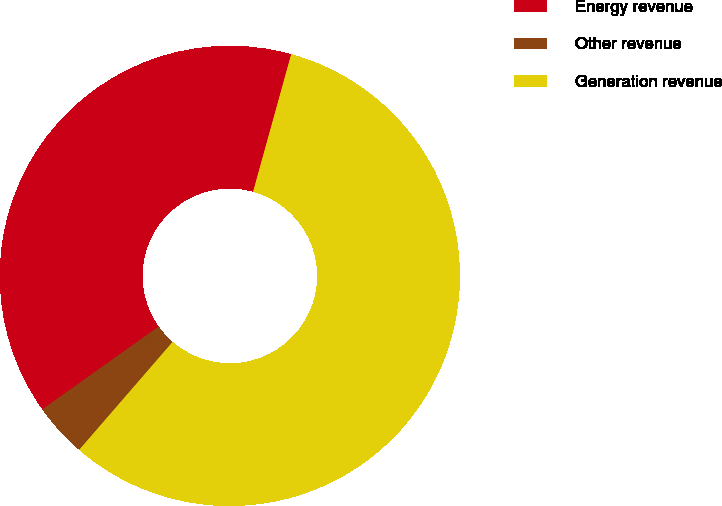Convert chart. <chart><loc_0><loc_0><loc_500><loc_500><pie_chart><fcel>Energy revenue<fcel>Other revenue<fcel>Generation revenue<nl><fcel>39.15%<fcel>3.8%<fcel>57.06%<nl></chart> 